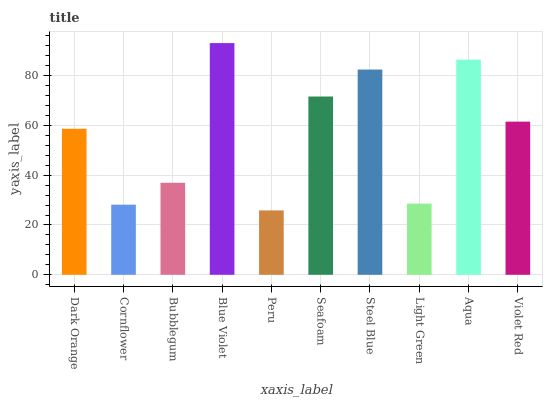Is Peru the minimum?
Answer yes or no. Yes. Is Blue Violet the maximum?
Answer yes or no. Yes. Is Cornflower the minimum?
Answer yes or no. No. Is Cornflower the maximum?
Answer yes or no. No. Is Dark Orange greater than Cornflower?
Answer yes or no. Yes. Is Cornflower less than Dark Orange?
Answer yes or no. Yes. Is Cornflower greater than Dark Orange?
Answer yes or no. No. Is Dark Orange less than Cornflower?
Answer yes or no. No. Is Violet Red the high median?
Answer yes or no. Yes. Is Dark Orange the low median?
Answer yes or no. Yes. Is Blue Violet the high median?
Answer yes or no. No. Is Steel Blue the low median?
Answer yes or no. No. 